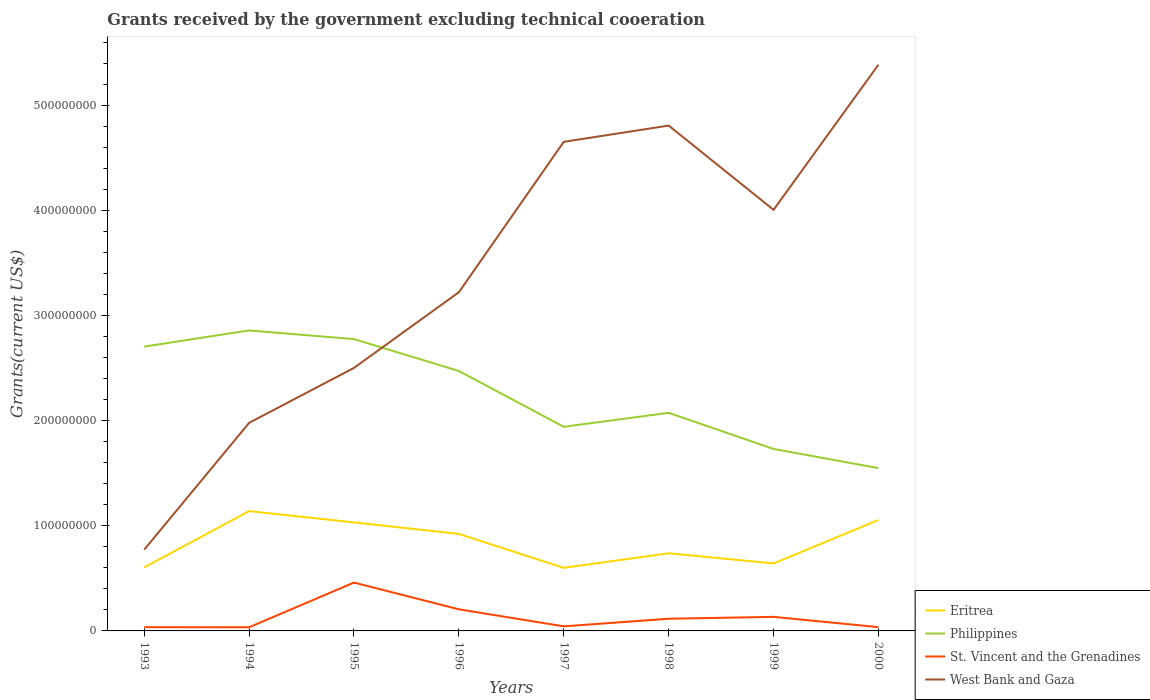How many different coloured lines are there?
Your response must be concise. 4. Does the line corresponding to West Bank and Gaza intersect with the line corresponding to Philippines?
Offer a very short reply. Yes. Is the number of lines equal to the number of legend labels?
Your answer should be very brief. Yes. Across all years, what is the maximum total grants received by the government in West Bank and Gaza?
Your answer should be compact. 7.73e+07. What is the total total grants received by the government in Eritrea in the graph?
Keep it short and to the point. 2.81e+07. What is the difference between the highest and the second highest total grants received by the government in Eritrea?
Make the answer very short. 5.39e+07. What is the difference between the highest and the lowest total grants received by the government in St. Vincent and the Grenadines?
Your answer should be compact. 3. Is the total grants received by the government in Philippines strictly greater than the total grants received by the government in St. Vincent and the Grenadines over the years?
Offer a terse response. No. How many lines are there?
Keep it short and to the point. 4. What is the difference between two consecutive major ticks on the Y-axis?
Ensure brevity in your answer.  1.00e+08. Are the values on the major ticks of Y-axis written in scientific E-notation?
Give a very brief answer. No. Where does the legend appear in the graph?
Provide a succinct answer. Bottom right. How are the legend labels stacked?
Offer a very short reply. Vertical. What is the title of the graph?
Your response must be concise. Grants received by the government excluding technical cooeration. Does "Libya" appear as one of the legend labels in the graph?
Ensure brevity in your answer.  No. What is the label or title of the X-axis?
Offer a terse response. Years. What is the label or title of the Y-axis?
Your answer should be compact. Grants(current US$). What is the Grants(current US$) of Eritrea in 1993?
Your answer should be compact. 6.04e+07. What is the Grants(current US$) of Philippines in 1993?
Your answer should be compact. 2.70e+08. What is the Grants(current US$) of St. Vincent and the Grenadines in 1993?
Give a very brief answer. 3.53e+06. What is the Grants(current US$) of West Bank and Gaza in 1993?
Provide a short and direct response. 7.73e+07. What is the Grants(current US$) of Eritrea in 1994?
Provide a short and direct response. 1.14e+08. What is the Grants(current US$) in Philippines in 1994?
Your answer should be very brief. 2.86e+08. What is the Grants(current US$) in St. Vincent and the Grenadines in 1994?
Give a very brief answer. 3.47e+06. What is the Grants(current US$) in West Bank and Gaza in 1994?
Provide a succinct answer. 1.98e+08. What is the Grants(current US$) of Eritrea in 1995?
Make the answer very short. 1.03e+08. What is the Grants(current US$) of Philippines in 1995?
Give a very brief answer. 2.78e+08. What is the Grants(current US$) of St. Vincent and the Grenadines in 1995?
Your response must be concise. 4.60e+07. What is the Grants(current US$) of West Bank and Gaza in 1995?
Give a very brief answer. 2.50e+08. What is the Grants(current US$) of Eritrea in 1996?
Offer a terse response. 9.22e+07. What is the Grants(current US$) in Philippines in 1996?
Provide a succinct answer. 2.47e+08. What is the Grants(current US$) in St. Vincent and the Grenadines in 1996?
Ensure brevity in your answer.  2.06e+07. What is the Grants(current US$) in West Bank and Gaza in 1996?
Offer a terse response. 3.22e+08. What is the Grants(current US$) of Eritrea in 1997?
Provide a short and direct response. 6.00e+07. What is the Grants(current US$) in Philippines in 1997?
Provide a short and direct response. 1.94e+08. What is the Grants(current US$) in St. Vincent and the Grenadines in 1997?
Make the answer very short. 4.35e+06. What is the Grants(current US$) in West Bank and Gaza in 1997?
Your response must be concise. 4.65e+08. What is the Grants(current US$) of Eritrea in 1998?
Offer a very short reply. 7.39e+07. What is the Grants(current US$) of Philippines in 1998?
Offer a terse response. 2.07e+08. What is the Grants(current US$) in St. Vincent and the Grenadines in 1998?
Ensure brevity in your answer.  1.16e+07. What is the Grants(current US$) of West Bank and Gaza in 1998?
Your answer should be very brief. 4.81e+08. What is the Grants(current US$) in Eritrea in 1999?
Keep it short and to the point. 6.42e+07. What is the Grants(current US$) of Philippines in 1999?
Your response must be concise. 1.73e+08. What is the Grants(current US$) of St. Vincent and the Grenadines in 1999?
Give a very brief answer. 1.34e+07. What is the Grants(current US$) of West Bank and Gaza in 1999?
Keep it short and to the point. 4.01e+08. What is the Grants(current US$) in Eritrea in 2000?
Offer a very short reply. 1.06e+08. What is the Grants(current US$) in Philippines in 2000?
Provide a succinct answer. 1.55e+08. What is the Grants(current US$) in St. Vincent and the Grenadines in 2000?
Provide a short and direct response. 3.59e+06. What is the Grants(current US$) in West Bank and Gaza in 2000?
Give a very brief answer. 5.39e+08. Across all years, what is the maximum Grants(current US$) of Eritrea?
Your answer should be compact. 1.14e+08. Across all years, what is the maximum Grants(current US$) in Philippines?
Ensure brevity in your answer.  2.86e+08. Across all years, what is the maximum Grants(current US$) of St. Vincent and the Grenadines?
Provide a short and direct response. 4.60e+07. Across all years, what is the maximum Grants(current US$) in West Bank and Gaza?
Offer a very short reply. 5.39e+08. Across all years, what is the minimum Grants(current US$) in Eritrea?
Your answer should be very brief. 6.00e+07. Across all years, what is the minimum Grants(current US$) in Philippines?
Your answer should be compact. 1.55e+08. Across all years, what is the minimum Grants(current US$) of St. Vincent and the Grenadines?
Provide a short and direct response. 3.47e+06. Across all years, what is the minimum Grants(current US$) in West Bank and Gaza?
Offer a terse response. 7.73e+07. What is the total Grants(current US$) of Eritrea in the graph?
Keep it short and to the point. 6.73e+08. What is the total Grants(current US$) of Philippines in the graph?
Provide a succinct answer. 1.81e+09. What is the total Grants(current US$) of St. Vincent and the Grenadines in the graph?
Provide a short and direct response. 1.06e+08. What is the total Grants(current US$) in West Bank and Gaza in the graph?
Give a very brief answer. 2.73e+09. What is the difference between the Grants(current US$) of Eritrea in 1993 and that in 1994?
Offer a very short reply. -5.35e+07. What is the difference between the Grants(current US$) in Philippines in 1993 and that in 1994?
Make the answer very short. -1.54e+07. What is the difference between the Grants(current US$) of West Bank and Gaza in 1993 and that in 1994?
Provide a short and direct response. -1.21e+08. What is the difference between the Grants(current US$) in Eritrea in 1993 and that in 1995?
Your answer should be very brief. -4.28e+07. What is the difference between the Grants(current US$) of Philippines in 1993 and that in 1995?
Your answer should be very brief. -7.13e+06. What is the difference between the Grants(current US$) in St. Vincent and the Grenadines in 1993 and that in 1995?
Your answer should be compact. -4.24e+07. What is the difference between the Grants(current US$) in West Bank and Gaza in 1993 and that in 1995?
Keep it short and to the point. -1.73e+08. What is the difference between the Grants(current US$) of Eritrea in 1993 and that in 1996?
Your answer should be compact. -3.18e+07. What is the difference between the Grants(current US$) of Philippines in 1993 and that in 1996?
Keep it short and to the point. 2.32e+07. What is the difference between the Grants(current US$) of St. Vincent and the Grenadines in 1993 and that in 1996?
Offer a terse response. -1.70e+07. What is the difference between the Grants(current US$) in West Bank and Gaza in 1993 and that in 1996?
Provide a short and direct response. -2.45e+08. What is the difference between the Grants(current US$) of Philippines in 1993 and that in 1997?
Make the answer very short. 7.63e+07. What is the difference between the Grants(current US$) in St. Vincent and the Grenadines in 1993 and that in 1997?
Offer a very short reply. -8.20e+05. What is the difference between the Grants(current US$) in West Bank and Gaza in 1993 and that in 1997?
Ensure brevity in your answer.  -3.88e+08. What is the difference between the Grants(current US$) of Eritrea in 1993 and that in 1998?
Offer a very short reply. -1.35e+07. What is the difference between the Grants(current US$) in Philippines in 1993 and that in 1998?
Your response must be concise. 6.30e+07. What is the difference between the Grants(current US$) in St. Vincent and the Grenadines in 1993 and that in 1998?
Make the answer very short. -8.06e+06. What is the difference between the Grants(current US$) of West Bank and Gaza in 1993 and that in 1998?
Your answer should be very brief. -4.03e+08. What is the difference between the Grants(current US$) in Eritrea in 1993 and that in 1999?
Your answer should be very brief. -3.78e+06. What is the difference between the Grants(current US$) in Philippines in 1993 and that in 1999?
Give a very brief answer. 9.74e+07. What is the difference between the Grants(current US$) of St. Vincent and the Grenadines in 1993 and that in 1999?
Give a very brief answer. -9.84e+06. What is the difference between the Grants(current US$) of West Bank and Gaza in 1993 and that in 1999?
Offer a very short reply. -3.23e+08. What is the difference between the Grants(current US$) in Eritrea in 1993 and that in 2000?
Your answer should be very brief. -4.51e+07. What is the difference between the Grants(current US$) of Philippines in 1993 and that in 2000?
Provide a succinct answer. 1.16e+08. What is the difference between the Grants(current US$) of St. Vincent and the Grenadines in 1993 and that in 2000?
Provide a short and direct response. -6.00e+04. What is the difference between the Grants(current US$) in West Bank and Gaza in 1993 and that in 2000?
Your answer should be very brief. -4.61e+08. What is the difference between the Grants(current US$) in Eritrea in 1994 and that in 1995?
Your answer should be very brief. 1.07e+07. What is the difference between the Grants(current US$) in Philippines in 1994 and that in 1995?
Make the answer very short. 8.22e+06. What is the difference between the Grants(current US$) in St. Vincent and the Grenadines in 1994 and that in 1995?
Make the answer very short. -4.25e+07. What is the difference between the Grants(current US$) of West Bank and Gaza in 1994 and that in 1995?
Offer a very short reply. -5.23e+07. What is the difference between the Grants(current US$) in Eritrea in 1994 and that in 1996?
Your response must be concise. 2.17e+07. What is the difference between the Grants(current US$) of Philippines in 1994 and that in 1996?
Keep it short and to the point. 3.86e+07. What is the difference between the Grants(current US$) of St. Vincent and the Grenadines in 1994 and that in 1996?
Make the answer very short. -1.71e+07. What is the difference between the Grants(current US$) in West Bank and Gaza in 1994 and that in 1996?
Provide a succinct answer. -1.24e+08. What is the difference between the Grants(current US$) in Eritrea in 1994 and that in 1997?
Provide a succinct answer. 5.39e+07. What is the difference between the Grants(current US$) of Philippines in 1994 and that in 1997?
Ensure brevity in your answer.  9.16e+07. What is the difference between the Grants(current US$) in St. Vincent and the Grenadines in 1994 and that in 1997?
Your answer should be very brief. -8.80e+05. What is the difference between the Grants(current US$) in West Bank and Gaza in 1994 and that in 1997?
Your answer should be compact. -2.67e+08. What is the difference between the Grants(current US$) of Eritrea in 1994 and that in 1998?
Provide a short and direct response. 4.01e+07. What is the difference between the Grants(current US$) in Philippines in 1994 and that in 1998?
Provide a succinct answer. 7.84e+07. What is the difference between the Grants(current US$) of St. Vincent and the Grenadines in 1994 and that in 1998?
Your response must be concise. -8.12e+06. What is the difference between the Grants(current US$) in West Bank and Gaza in 1994 and that in 1998?
Keep it short and to the point. -2.83e+08. What is the difference between the Grants(current US$) in Eritrea in 1994 and that in 1999?
Give a very brief answer. 4.98e+07. What is the difference between the Grants(current US$) of Philippines in 1994 and that in 1999?
Your answer should be very brief. 1.13e+08. What is the difference between the Grants(current US$) in St. Vincent and the Grenadines in 1994 and that in 1999?
Your answer should be compact. -9.90e+06. What is the difference between the Grants(current US$) of West Bank and Gaza in 1994 and that in 1999?
Provide a short and direct response. -2.03e+08. What is the difference between the Grants(current US$) in Eritrea in 1994 and that in 2000?
Provide a succinct answer. 8.42e+06. What is the difference between the Grants(current US$) in Philippines in 1994 and that in 2000?
Provide a short and direct response. 1.31e+08. What is the difference between the Grants(current US$) in St. Vincent and the Grenadines in 1994 and that in 2000?
Your answer should be compact. -1.20e+05. What is the difference between the Grants(current US$) in West Bank and Gaza in 1994 and that in 2000?
Ensure brevity in your answer.  -3.41e+08. What is the difference between the Grants(current US$) in Eritrea in 1995 and that in 1996?
Offer a very short reply. 1.10e+07. What is the difference between the Grants(current US$) in Philippines in 1995 and that in 1996?
Ensure brevity in your answer.  3.04e+07. What is the difference between the Grants(current US$) in St. Vincent and the Grenadines in 1995 and that in 1996?
Provide a succinct answer. 2.54e+07. What is the difference between the Grants(current US$) of West Bank and Gaza in 1995 and that in 1996?
Keep it short and to the point. -7.20e+07. What is the difference between the Grants(current US$) in Eritrea in 1995 and that in 1997?
Offer a very short reply. 4.32e+07. What is the difference between the Grants(current US$) of Philippines in 1995 and that in 1997?
Provide a succinct answer. 8.34e+07. What is the difference between the Grants(current US$) in St. Vincent and the Grenadines in 1995 and that in 1997?
Ensure brevity in your answer.  4.16e+07. What is the difference between the Grants(current US$) of West Bank and Gaza in 1995 and that in 1997?
Your answer should be very brief. -2.15e+08. What is the difference between the Grants(current US$) in Eritrea in 1995 and that in 1998?
Keep it short and to the point. 2.94e+07. What is the difference between the Grants(current US$) in Philippines in 1995 and that in 1998?
Your answer should be very brief. 7.01e+07. What is the difference between the Grants(current US$) of St. Vincent and the Grenadines in 1995 and that in 1998?
Provide a short and direct response. 3.44e+07. What is the difference between the Grants(current US$) of West Bank and Gaza in 1995 and that in 1998?
Make the answer very short. -2.30e+08. What is the difference between the Grants(current US$) in Eritrea in 1995 and that in 1999?
Offer a terse response. 3.90e+07. What is the difference between the Grants(current US$) in Philippines in 1995 and that in 1999?
Your answer should be compact. 1.04e+08. What is the difference between the Grants(current US$) of St. Vincent and the Grenadines in 1995 and that in 1999?
Offer a very short reply. 3.26e+07. What is the difference between the Grants(current US$) of West Bank and Gaza in 1995 and that in 1999?
Provide a short and direct response. -1.50e+08. What is the difference between the Grants(current US$) in Eritrea in 1995 and that in 2000?
Your response must be concise. -2.29e+06. What is the difference between the Grants(current US$) of Philippines in 1995 and that in 2000?
Provide a succinct answer. 1.23e+08. What is the difference between the Grants(current US$) in St. Vincent and the Grenadines in 1995 and that in 2000?
Offer a very short reply. 4.24e+07. What is the difference between the Grants(current US$) of West Bank and Gaza in 1995 and that in 2000?
Offer a very short reply. -2.88e+08. What is the difference between the Grants(current US$) in Eritrea in 1996 and that in 1997?
Offer a very short reply. 3.22e+07. What is the difference between the Grants(current US$) of Philippines in 1996 and that in 1997?
Provide a short and direct response. 5.30e+07. What is the difference between the Grants(current US$) in St. Vincent and the Grenadines in 1996 and that in 1997?
Ensure brevity in your answer.  1.62e+07. What is the difference between the Grants(current US$) of West Bank and Gaza in 1996 and that in 1997?
Your answer should be very brief. -1.43e+08. What is the difference between the Grants(current US$) in Eritrea in 1996 and that in 1998?
Your response must be concise. 1.84e+07. What is the difference between the Grants(current US$) of Philippines in 1996 and that in 1998?
Your response must be concise. 3.98e+07. What is the difference between the Grants(current US$) in St. Vincent and the Grenadines in 1996 and that in 1998?
Provide a succinct answer. 8.96e+06. What is the difference between the Grants(current US$) in West Bank and Gaza in 1996 and that in 1998?
Give a very brief answer. -1.59e+08. What is the difference between the Grants(current US$) in Eritrea in 1996 and that in 1999?
Your response must be concise. 2.81e+07. What is the difference between the Grants(current US$) in Philippines in 1996 and that in 1999?
Your answer should be compact. 7.41e+07. What is the difference between the Grants(current US$) of St. Vincent and the Grenadines in 1996 and that in 1999?
Keep it short and to the point. 7.18e+06. What is the difference between the Grants(current US$) in West Bank and Gaza in 1996 and that in 1999?
Your response must be concise. -7.84e+07. What is the difference between the Grants(current US$) in Eritrea in 1996 and that in 2000?
Make the answer very short. -1.33e+07. What is the difference between the Grants(current US$) of Philippines in 1996 and that in 2000?
Offer a terse response. 9.24e+07. What is the difference between the Grants(current US$) of St. Vincent and the Grenadines in 1996 and that in 2000?
Your response must be concise. 1.70e+07. What is the difference between the Grants(current US$) in West Bank and Gaza in 1996 and that in 2000?
Your answer should be very brief. -2.16e+08. What is the difference between the Grants(current US$) of Eritrea in 1997 and that in 1998?
Your response must be concise. -1.38e+07. What is the difference between the Grants(current US$) in Philippines in 1997 and that in 1998?
Give a very brief answer. -1.33e+07. What is the difference between the Grants(current US$) of St. Vincent and the Grenadines in 1997 and that in 1998?
Offer a very short reply. -7.24e+06. What is the difference between the Grants(current US$) in West Bank and Gaza in 1997 and that in 1998?
Ensure brevity in your answer.  -1.54e+07. What is the difference between the Grants(current US$) in Eritrea in 1997 and that in 1999?
Provide a short and direct response. -4.17e+06. What is the difference between the Grants(current US$) in Philippines in 1997 and that in 1999?
Keep it short and to the point. 2.11e+07. What is the difference between the Grants(current US$) in St. Vincent and the Grenadines in 1997 and that in 1999?
Provide a succinct answer. -9.02e+06. What is the difference between the Grants(current US$) of West Bank and Gaza in 1997 and that in 1999?
Ensure brevity in your answer.  6.47e+07. What is the difference between the Grants(current US$) in Eritrea in 1997 and that in 2000?
Keep it short and to the point. -4.55e+07. What is the difference between the Grants(current US$) in Philippines in 1997 and that in 2000?
Offer a terse response. 3.93e+07. What is the difference between the Grants(current US$) in St. Vincent and the Grenadines in 1997 and that in 2000?
Provide a succinct answer. 7.60e+05. What is the difference between the Grants(current US$) in West Bank and Gaza in 1997 and that in 2000?
Your answer should be very brief. -7.34e+07. What is the difference between the Grants(current US$) of Eritrea in 1998 and that in 1999?
Offer a very short reply. 9.68e+06. What is the difference between the Grants(current US$) in Philippines in 1998 and that in 1999?
Keep it short and to the point. 3.44e+07. What is the difference between the Grants(current US$) of St. Vincent and the Grenadines in 1998 and that in 1999?
Offer a terse response. -1.78e+06. What is the difference between the Grants(current US$) in West Bank and Gaza in 1998 and that in 1999?
Your answer should be compact. 8.02e+07. What is the difference between the Grants(current US$) of Eritrea in 1998 and that in 2000?
Make the answer very short. -3.17e+07. What is the difference between the Grants(current US$) of Philippines in 1998 and that in 2000?
Make the answer very short. 5.26e+07. What is the difference between the Grants(current US$) in St. Vincent and the Grenadines in 1998 and that in 2000?
Your response must be concise. 8.00e+06. What is the difference between the Grants(current US$) in West Bank and Gaza in 1998 and that in 2000?
Make the answer very short. -5.79e+07. What is the difference between the Grants(current US$) of Eritrea in 1999 and that in 2000?
Provide a short and direct response. -4.13e+07. What is the difference between the Grants(current US$) in Philippines in 1999 and that in 2000?
Offer a very short reply. 1.82e+07. What is the difference between the Grants(current US$) in St. Vincent and the Grenadines in 1999 and that in 2000?
Your answer should be very brief. 9.78e+06. What is the difference between the Grants(current US$) in West Bank and Gaza in 1999 and that in 2000?
Your response must be concise. -1.38e+08. What is the difference between the Grants(current US$) of Eritrea in 1993 and the Grants(current US$) of Philippines in 1994?
Your answer should be very brief. -2.25e+08. What is the difference between the Grants(current US$) of Eritrea in 1993 and the Grants(current US$) of St. Vincent and the Grenadines in 1994?
Make the answer very short. 5.69e+07. What is the difference between the Grants(current US$) in Eritrea in 1993 and the Grants(current US$) in West Bank and Gaza in 1994?
Your answer should be compact. -1.38e+08. What is the difference between the Grants(current US$) in Philippines in 1993 and the Grants(current US$) in St. Vincent and the Grenadines in 1994?
Ensure brevity in your answer.  2.67e+08. What is the difference between the Grants(current US$) of Philippines in 1993 and the Grants(current US$) of West Bank and Gaza in 1994?
Give a very brief answer. 7.25e+07. What is the difference between the Grants(current US$) of St. Vincent and the Grenadines in 1993 and the Grants(current US$) of West Bank and Gaza in 1994?
Make the answer very short. -1.94e+08. What is the difference between the Grants(current US$) of Eritrea in 1993 and the Grants(current US$) of Philippines in 1995?
Provide a short and direct response. -2.17e+08. What is the difference between the Grants(current US$) of Eritrea in 1993 and the Grants(current US$) of St. Vincent and the Grenadines in 1995?
Keep it short and to the point. 1.44e+07. What is the difference between the Grants(current US$) in Eritrea in 1993 and the Grants(current US$) in West Bank and Gaza in 1995?
Your response must be concise. -1.90e+08. What is the difference between the Grants(current US$) in Philippines in 1993 and the Grants(current US$) in St. Vincent and the Grenadines in 1995?
Make the answer very short. 2.24e+08. What is the difference between the Grants(current US$) of Philippines in 1993 and the Grants(current US$) of West Bank and Gaza in 1995?
Offer a terse response. 2.03e+07. What is the difference between the Grants(current US$) of St. Vincent and the Grenadines in 1993 and the Grants(current US$) of West Bank and Gaza in 1995?
Provide a succinct answer. -2.47e+08. What is the difference between the Grants(current US$) of Eritrea in 1993 and the Grants(current US$) of Philippines in 1996?
Make the answer very short. -1.87e+08. What is the difference between the Grants(current US$) in Eritrea in 1993 and the Grants(current US$) in St. Vincent and the Grenadines in 1996?
Give a very brief answer. 3.98e+07. What is the difference between the Grants(current US$) in Eritrea in 1993 and the Grants(current US$) in West Bank and Gaza in 1996?
Ensure brevity in your answer.  -2.62e+08. What is the difference between the Grants(current US$) of Philippines in 1993 and the Grants(current US$) of St. Vincent and the Grenadines in 1996?
Provide a succinct answer. 2.50e+08. What is the difference between the Grants(current US$) of Philippines in 1993 and the Grants(current US$) of West Bank and Gaza in 1996?
Provide a succinct answer. -5.17e+07. What is the difference between the Grants(current US$) in St. Vincent and the Grenadines in 1993 and the Grants(current US$) in West Bank and Gaza in 1996?
Offer a terse response. -3.19e+08. What is the difference between the Grants(current US$) of Eritrea in 1993 and the Grants(current US$) of Philippines in 1997?
Provide a succinct answer. -1.34e+08. What is the difference between the Grants(current US$) of Eritrea in 1993 and the Grants(current US$) of St. Vincent and the Grenadines in 1997?
Ensure brevity in your answer.  5.60e+07. What is the difference between the Grants(current US$) in Eritrea in 1993 and the Grants(current US$) in West Bank and Gaza in 1997?
Your answer should be very brief. -4.05e+08. What is the difference between the Grants(current US$) of Philippines in 1993 and the Grants(current US$) of St. Vincent and the Grenadines in 1997?
Make the answer very short. 2.66e+08. What is the difference between the Grants(current US$) of Philippines in 1993 and the Grants(current US$) of West Bank and Gaza in 1997?
Give a very brief answer. -1.95e+08. What is the difference between the Grants(current US$) of St. Vincent and the Grenadines in 1993 and the Grants(current US$) of West Bank and Gaza in 1997?
Your response must be concise. -4.62e+08. What is the difference between the Grants(current US$) of Eritrea in 1993 and the Grants(current US$) of Philippines in 1998?
Your answer should be very brief. -1.47e+08. What is the difference between the Grants(current US$) in Eritrea in 1993 and the Grants(current US$) in St. Vincent and the Grenadines in 1998?
Offer a terse response. 4.88e+07. What is the difference between the Grants(current US$) of Eritrea in 1993 and the Grants(current US$) of West Bank and Gaza in 1998?
Your answer should be very brief. -4.20e+08. What is the difference between the Grants(current US$) in Philippines in 1993 and the Grants(current US$) in St. Vincent and the Grenadines in 1998?
Offer a very short reply. 2.59e+08. What is the difference between the Grants(current US$) in Philippines in 1993 and the Grants(current US$) in West Bank and Gaza in 1998?
Ensure brevity in your answer.  -2.10e+08. What is the difference between the Grants(current US$) in St. Vincent and the Grenadines in 1993 and the Grants(current US$) in West Bank and Gaza in 1998?
Provide a succinct answer. -4.77e+08. What is the difference between the Grants(current US$) of Eritrea in 1993 and the Grants(current US$) of Philippines in 1999?
Offer a very short reply. -1.13e+08. What is the difference between the Grants(current US$) of Eritrea in 1993 and the Grants(current US$) of St. Vincent and the Grenadines in 1999?
Keep it short and to the point. 4.70e+07. What is the difference between the Grants(current US$) of Eritrea in 1993 and the Grants(current US$) of West Bank and Gaza in 1999?
Your answer should be compact. -3.40e+08. What is the difference between the Grants(current US$) in Philippines in 1993 and the Grants(current US$) in St. Vincent and the Grenadines in 1999?
Provide a succinct answer. 2.57e+08. What is the difference between the Grants(current US$) in Philippines in 1993 and the Grants(current US$) in West Bank and Gaza in 1999?
Keep it short and to the point. -1.30e+08. What is the difference between the Grants(current US$) of St. Vincent and the Grenadines in 1993 and the Grants(current US$) of West Bank and Gaza in 1999?
Offer a very short reply. -3.97e+08. What is the difference between the Grants(current US$) in Eritrea in 1993 and the Grants(current US$) in Philippines in 2000?
Offer a terse response. -9.45e+07. What is the difference between the Grants(current US$) in Eritrea in 1993 and the Grants(current US$) in St. Vincent and the Grenadines in 2000?
Provide a succinct answer. 5.68e+07. What is the difference between the Grants(current US$) of Eritrea in 1993 and the Grants(current US$) of West Bank and Gaza in 2000?
Offer a very short reply. -4.78e+08. What is the difference between the Grants(current US$) of Philippines in 1993 and the Grants(current US$) of St. Vincent and the Grenadines in 2000?
Ensure brevity in your answer.  2.67e+08. What is the difference between the Grants(current US$) in Philippines in 1993 and the Grants(current US$) in West Bank and Gaza in 2000?
Make the answer very short. -2.68e+08. What is the difference between the Grants(current US$) of St. Vincent and the Grenadines in 1993 and the Grants(current US$) of West Bank and Gaza in 2000?
Your answer should be very brief. -5.35e+08. What is the difference between the Grants(current US$) of Eritrea in 1994 and the Grants(current US$) of Philippines in 1995?
Offer a very short reply. -1.64e+08. What is the difference between the Grants(current US$) in Eritrea in 1994 and the Grants(current US$) in St. Vincent and the Grenadines in 1995?
Your answer should be very brief. 6.80e+07. What is the difference between the Grants(current US$) of Eritrea in 1994 and the Grants(current US$) of West Bank and Gaza in 1995?
Make the answer very short. -1.36e+08. What is the difference between the Grants(current US$) in Philippines in 1994 and the Grants(current US$) in St. Vincent and the Grenadines in 1995?
Your answer should be very brief. 2.40e+08. What is the difference between the Grants(current US$) of Philippines in 1994 and the Grants(current US$) of West Bank and Gaza in 1995?
Your response must be concise. 3.56e+07. What is the difference between the Grants(current US$) in St. Vincent and the Grenadines in 1994 and the Grants(current US$) in West Bank and Gaza in 1995?
Keep it short and to the point. -2.47e+08. What is the difference between the Grants(current US$) of Eritrea in 1994 and the Grants(current US$) of Philippines in 1996?
Ensure brevity in your answer.  -1.33e+08. What is the difference between the Grants(current US$) of Eritrea in 1994 and the Grants(current US$) of St. Vincent and the Grenadines in 1996?
Ensure brevity in your answer.  9.34e+07. What is the difference between the Grants(current US$) of Eritrea in 1994 and the Grants(current US$) of West Bank and Gaza in 1996?
Offer a very short reply. -2.08e+08. What is the difference between the Grants(current US$) in Philippines in 1994 and the Grants(current US$) in St. Vincent and the Grenadines in 1996?
Offer a very short reply. 2.65e+08. What is the difference between the Grants(current US$) in Philippines in 1994 and the Grants(current US$) in West Bank and Gaza in 1996?
Ensure brevity in your answer.  -3.64e+07. What is the difference between the Grants(current US$) in St. Vincent and the Grenadines in 1994 and the Grants(current US$) in West Bank and Gaza in 1996?
Make the answer very short. -3.19e+08. What is the difference between the Grants(current US$) of Eritrea in 1994 and the Grants(current US$) of Philippines in 1997?
Make the answer very short. -8.02e+07. What is the difference between the Grants(current US$) in Eritrea in 1994 and the Grants(current US$) in St. Vincent and the Grenadines in 1997?
Give a very brief answer. 1.10e+08. What is the difference between the Grants(current US$) of Eritrea in 1994 and the Grants(current US$) of West Bank and Gaza in 1997?
Ensure brevity in your answer.  -3.51e+08. What is the difference between the Grants(current US$) of Philippines in 1994 and the Grants(current US$) of St. Vincent and the Grenadines in 1997?
Your answer should be compact. 2.81e+08. What is the difference between the Grants(current US$) in Philippines in 1994 and the Grants(current US$) in West Bank and Gaza in 1997?
Give a very brief answer. -1.79e+08. What is the difference between the Grants(current US$) of St. Vincent and the Grenadines in 1994 and the Grants(current US$) of West Bank and Gaza in 1997?
Your answer should be compact. -4.62e+08. What is the difference between the Grants(current US$) of Eritrea in 1994 and the Grants(current US$) of Philippines in 1998?
Keep it short and to the point. -9.35e+07. What is the difference between the Grants(current US$) in Eritrea in 1994 and the Grants(current US$) in St. Vincent and the Grenadines in 1998?
Provide a succinct answer. 1.02e+08. What is the difference between the Grants(current US$) in Eritrea in 1994 and the Grants(current US$) in West Bank and Gaza in 1998?
Provide a short and direct response. -3.67e+08. What is the difference between the Grants(current US$) in Philippines in 1994 and the Grants(current US$) in St. Vincent and the Grenadines in 1998?
Your response must be concise. 2.74e+08. What is the difference between the Grants(current US$) of Philippines in 1994 and the Grants(current US$) of West Bank and Gaza in 1998?
Your response must be concise. -1.95e+08. What is the difference between the Grants(current US$) in St. Vincent and the Grenadines in 1994 and the Grants(current US$) in West Bank and Gaza in 1998?
Your answer should be very brief. -4.77e+08. What is the difference between the Grants(current US$) in Eritrea in 1994 and the Grants(current US$) in Philippines in 1999?
Offer a terse response. -5.91e+07. What is the difference between the Grants(current US$) in Eritrea in 1994 and the Grants(current US$) in St. Vincent and the Grenadines in 1999?
Your answer should be very brief. 1.01e+08. What is the difference between the Grants(current US$) of Eritrea in 1994 and the Grants(current US$) of West Bank and Gaza in 1999?
Provide a short and direct response. -2.87e+08. What is the difference between the Grants(current US$) of Philippines in 1994 and the Grants(current US$) of St. Vincent and the Grenadines in 1999?
Ensure brevity in your answer.  2.72e+08. What is the difference between the Grants(current US$) in Philippines in 1994 and the Grants(current US$) in West Bank and Gaza in 1999?
Offer a terse response. -1.15e+08. What is the difference between the Grants(current US$) in St. Vincent and the Grenadines in 1994 and the Grants(current US$) in West Bank and Gaza in 1999?
Provide a short and direct response. -3.97e+08. What is the difference between the Grants(current US$) of Eritrea in 1994 and the Grants(current US$) of Philippines in 2000?
Your answer should be very brief. -4.09e+07. What is the difference between the Grants(current US$) of Eritrea in 1994 and the Grants(current US$) of St. Vincent and the Grenadines in 2000?
Your answer should be compact. 1.10e+08. What is the difference between the Grants(current US$) of Eritrea in 1994 and the Grants(current US$) of West Bank and Gaza in 2000?
Offer a terse response. -4.25e+08. What is the difference between the Grants(current US$) of Philippines in 1994 and the Grants(current US$) of St. Vincent and the Grenadines in 2000?
Your answer should be compact. 2.82e+08. What is the difference between the Grants(current US$) in Philippines in 1994 and the Grants(current US$) in West Bank and Gaza in 2000?
Your answer should be compact. -2.53e+08. What is the difference between the Grants(current US$) in St. Vincent and the Grenadines in 1994 and the Grants(current US$) in West Bank and Gaza in 2000?
Provide a succinct answer. -5.35e+08. What is the difference between the Grants(current US$) of Eritrea in 1995 and the Grants(current US$) of Philippines in 1996?
Offer a terse response. -1.44e+08. What is the difference between the Grants(current US$) in Eritrea in 1995 and the Grants(current US$) in St. Vincent and the Grenadines in 1996?
Offer a very short reply. 8.27e+07. What is the difference between the Grants(current US$) of Eritrea in 1995 and the Grants(current US$) of West Bank and Gaza in 1996?
Provide a short and direct response. -2.19e+08. What is the difference between the Grants(current US$) in Philippines in 1995 and the Grants(current US$) in St. Vincent and the Grenadines in 1996?
Make the answer very short. 2.57e+08. What is the difference between the Grants(current US$) of Philippines in 1995 and the Grants(current US$) of West Bank and Gaza in 1996?
Offer a very short reply. -4.46e+07. What is the difference between the Grants(current US$) in St. Vincent and the Grenadines in 1995 and the Grants(current US$) in West Bank and Gaza in 1996?
Keep it short and to the point. -2.76e+08. What is the difference between the Grants(current US$) of Eritrea in 1995 and the Grants(current US$) of Philippines in 1997?
Keep it short and to the point. -9.10e+07. What is the difference between the Grants(current US$) of Eritrea in 1995 and the Grants(current US$) of St. Vincent and the Grenadines in 1997?
Your response must be concise. 9.89e+07. What is the difference between the Grants(current US$) in Eritrea in 1995 and the Grants(current US$) in West Bank and Gaza in 1997?
Make the answer very short. -3.62e+08. What is the difference between the Grants(current US$) in Philippines in 1995 and the Grants(current US$) in St. Vincent and the Grenadines in 1997?
Your response must be concise. 2.73e+08. What is the difference between the Grants(current US$) in Philippines in 1995 and the Grants(current US$) in West Bank and Gaza in 1997?
Your answer should be very brief. -1.88e+08. What is the difference between the Grants(current US$) of St. Vincent and the Grenadines in 1995 and the Grants(current US$) of West Bank and Gaza in 1997?
Ensure brevity in your answer.  -4.19e+08. What is the difference between the Grants(current US$) of Eritrea in 1995 and the Grants(current US$) of Philippines in 1998?
Your answer should be very brief. -1.04e+08. What is the difference between the Grants(current US$) in Eritrea in 1995 and the Grants(current US$) in St. Vincent and the Grenadines in 1998?
Provide a succinct answer. 9.16e+07. What is the difference between the Grants(current US$) in Eritrea in 1995 and the Grants(current US$) in West Bank and Gaza in 1998?
Provide a succinct answer. -3.77e+08. What is the difference between the Grants(current US$) in Philippines in 1995 and the Grants(current US$) in St. Vincent and the Grenadines in 1998?
Provide a short and direct response. 2.66e+08. What is the difference between the Grants(current US$) in Philippines in 1995 and the Grants(current US$) in West Bank and Gaza in 1998?
Provide a succinct answer. -2.03e+08. What is the difference between the Grants(current US$) of St. Vincent and the Grenadines in 1995 and the Grants(current US$) of West Bank and Gaza in 1998?
Offer a very short reply. -4.35e+08. What is the difference between the Grants(current US$) of Eritrea in 1995 and the Grants(current US$) of Philippines in 1999?
Make the answer very short. -6.98e+07. What is the difference between the Grants(current US$) of Eritrea in 1995 and the Grants(current US$) of St. Vincent and the Grenadines in 1999?
Offer a very short reply. 8.99e+07. What is the difference between the Grants(current US$) of Eritrea in 1995 and the Grants(current US$) of West Bank and Gaza in 1999?
Ensure brevity in your answer.  -2.97e+08. What is the difference between the Grants(current US$) in Philippines in 1995 and the Grants(current US$) in St. Vincent and the Grenadines in 1999?
Your response must be concise. 2.64e+08. What is the difference between the Grants(current US$) of Philippines in 1995 and the Grants(current US$) of West Bank and Gaza in 1999?
Provide a succinct answer. -1.23e+08. What is the difference between the Grants(current US$) of St. Vincent and the Grenadines in 1995 and the Grants(current US$) of West Bank and Gaza in 1999?
Your answer should be compact. -3.55e+08. What is the difference between the Grants(current US$) in Eritrea in 1995 and the Grants(current US$) in Philippines in 2000?
Offer a very short reply. -5.16e+07. What is the difference between the Grants(current US$) of Eritrea in 1995 and the Grants(current US$) of St. Vincent and the Grenadines in 2000?
Provide a short and direct response. 9.96e+07. What is the difference between the Grants(current US$) of Eritrea in 1995 and the Grants(current US$) of West Bank and Gaza in 2000?
Provide a short and direct response. -4.35e+08. What is the difference between the Grants(current US$) in Philippines in 1995 and the Grants(current US$) in St. Vincent and the Grenadines in 2000?
Offer a very short reply. 2.74e+08. What is the difference between the Grants(current US$) of Philippines in 1995 and the Grants(current US$) of West Bank and Gaza in 2000?
Offer a terse response. -2.61e+08. What is the difference between the Grants(current US$) of St. Vincent and the Grenadines in 1995 and the Grants(current US$) of West Bank and Gaza in 2000?
Keep it short and to the point. -4.93e+08. What is the difference between the Grants(current US$) of Eritrea in 1996 and the Grants(current US$) of Philippines in 1997?
Offer a terse response. -1.02e+08. What is the difference between the Grants(current US$) in Eritrea in 1996 and the Grants(current US$) in St. Vincent and the Grenadines in 1997?
Keep it short and to the point. 8.79e+07. What is the difference between the Grants(current US$) of Eritrea in 1996 and the Grants(current US$) of West Bank and Gaza in 1997?
Your answer should be compact. -3.73e+08. What is the difference between the Grants(current US$) of Philippines in 1996 and the Grants(current US$) of St. Vincent and the Grenadines in 1997?
Offer a terse response. 2.43e+08. What is the difference between the Grants(current US$) of Philippines in 1996 and the Grants(current US$) of West Bank and Gaza in 1997?
Your answer should be compact. -2.18e+08. What is the difference between the Grants(current US$) in St. Vincent and the Grenadines in 1996 and the Grants(current US$) in West Bank and Gaza in 1997?
Provide a succinct answer. -4.45e+08. What is the difference between the Grants(current US$) in Eritrea in 1996 and the Grants(current US$) in Philippines in 1998?
Provide a short and direct response. -1.15e+08. What is the difference between the Grants(current US$) in Eritrea in 1996 and the Grants(current US$) in St. Vincent and the Grenadines in 1998?
Ensure brevity in your answer.  8.07e+07. What is the difference between the Grants(current US$) in Eritrea in 1996 and the Grants(current US$) in West Bank and Gaza in 1998?
Your answer should be very brief. -3.88e+08. What is the difference between the Grants(current US$) in Philippines in 1996 and the Grants(current US$) in St. Vincent and the Grenadines in 1998?
Provide a short and direct response. 2.36e+08. What is the difference between the Grants(current US$) of Philippines in 1996 and the Grants(current US$) of West Bank and Gaza in 1998?
Make the answer very short. -2.33e+08. What is the difference between the Grants(current US$) in St. Vincent and the Grenadines in 1996 and the Grants(current US$) in West Bank and Gaza in 1998?
Provide a short and direct response. -4.60e+08. What is the difference between the Grants(current US$) of Eritrea in 1996 and the Grants(current US$) of Philippines in 1999?
Your response must be concise. -8.08e+07. What is the difference between the Grants(current US$) in Eritrea in 1996 and the Grants(current US$) in St. Vincent and the Grenadines in 1999?
Your response must be concise. 7.89e+07. What is the difference between the Grants(current US$) in Eritrea in 1996 and the Grants(current US$) in West Bank and Gaza in 1999?
Keep it short and to the point. -3.08e+08. What is the difference between the Grants(current US$) of Philippines in 1996 and the Grants(current US$) of St. Vincent and the Grenadines in 1999?
Provide a succinct answer. 2.34e+08. What is the difference between the Grants(current US$) of Philippines in 1996 and the Grants(current US$) of West Bank and Gaza in 1999?
Ensure brevity in your answer.  -1.53e+08. What is the difference between the Grants(current US$) of St. Vincent and the Grenadines in 1996 and the Grants(current US$) of West Bank and Gaza in 1999?
Offer a terse response. -3.80e+08. What is the difference between the Grants(current US$) of Eritrea in 1996 and the Grants(current US$) of Philippines in 2000?
Provide a short and direct response. -6.26e+07. What is the difference between the Grants(current US$) in Eritrea in 1996 and the Grants(current US$) in St. Vincent and the Grenadines in 2000?
Offer a terse response. 8.87e+07. What is the difference between the Grants(current US$) of Eritrea in 1996 and the Grants(current US$) of West Bank and Gaza in 2000?
Your response must be concise. -4.46e+08. What is the difference between the Grants(current US$) of Philippines in 1996 and the Grants(current US$) of St. Vincent and the Grenadines in 2000?
Ensure brevity in your answer.  2.44e+08. What is the difference between the Grants(current US$) in Philippines in 1996 and the Grants(current US$) in West Bank and Gaza in 2000?
Your answer should be very brief. -2.91e+08. What is the difference between the Grants(current US$) in St. Vincent and the Grenadines in 1996 and the Grants(current US$) in West Bank and Gaza in 2000?
Your response must be concise. -5.18e+08. What is the difference between the Grants(current US$) in Eritrea in 1997 and the Grants(current US$) in Philippines in 1998?
Your answer should be compact. -1.47e+08. What is the difference between the Grants(current US$) in Eritrea in 1997 and the Grants(current US$) in St. Vincent and the Grenadines in 1998?
Give a very brief answer. 4.84e+07. What is the difference between the Grants(current US$) in Eritrea in 1997 and the Grants(current US$) in West Bank and Gaza in 1998?
Provide a succinct answer. -4.21e+08. What is the difference between the Grants(current US$) of Philippines in 1997 and the Grants(current US$) of St. Vincent and the Grenadines in 1998?
Keep it short and to the point. 1.83e+08. What is the difference between the Grants(current US$) of Philippines in 1997 and the Grants(current US$) of West Bank and Gaza in 1998?
Provide a short and direct response. -2.86e+08. What is the difference between the Grants(current US$) in St. Vincent and the Grenadines in 1997 and the Grants(current US$) in West Bank and Gaza in 1998?
Ensure brevity in your answer.  -4.76e+08. What is the difference between the Grants(current US$) in Eritrea in 1997 and the Grants(current US$) in Philippines in 1999?
Provide a succinct answer. -1.13e+08. What is the difference between the Grants(current US$) of Eritrea in 1997 and the Grants(current US$) of St. Vincent and the Grenadines in 1999?
Offer a very short reply. 4.66e+07. What is the difference between the Grants(current US$) in Eritrea in 1997 and the Grants(current US$) in West Bank and Gaza in 1999?
Your answer should be compact. -3.41e+08. What is the difference between the Grants(current US$) in Philippines in 1997 and the Grants(current US$) in St. Vincent and the Grenadines in 1999?
Offer a very short reply. 1.81e+08. What is the difference between the Grants(current US$) of Philippines in 1997 and the Grants(current US$) of West Bank and Gaza in 1999?
Your answer should be very brief. -2.06e+08. What is the difference between the Grants(current US$) in St. Vincent and the Grenadines in 1997 and the Grants(current US$) in West Bank and Gaza in 1999?
Give a very brief answer. -3.96e+08. What is the difference between the Grants(current US$) of Eritrea in 1997 and the Grants(current US$) of Philippines in 2000?
Provide a succinct answer. -9.49e+07. What is the difference between the Grants(current US$) of Eritrea in 1997 and the Grants(current US$) of St. Vincent and the Grenadines in 2000?
Ensure brevity in your answer.  5.64e+07. What is the difference between the Grants(current US$) of Eritrea in 1997 and the Grants(current US$) of West Bank and Gaza in 2000?
Your response must be concise. -4.79e+08. What is the difference between the Grants(current US$) of Philippines in 1997 and the Grants(current US$) of St. Vincent and the Grenadines in 2000?
Ensure brevity in your answer.  1.91e+08. What is the difference between the Grants(current US$) in Philippines in 1997 and the Grants(current US$) in West Bank and Gaza in 2000?
Your answer should be very brief. -3.44e+08. What is the difference between the Grants(current US$) of St. Vincent and the Grenadines in 1997 and the Grants(current US$) of West Bank and Gaza in 2000?
Give a very brief answer. -5.34e+08. What is the difference between the Grants(current US$) of Eritrea in 1998 and the Grants(current US$) of Philippines in 1999?
Your answer should be very brief. -9.92e+07. What is the difference between the Grants(current US$) in Eritrea in 1998 and the Grants(current US$) in St. Vincent and the Grenadines in 1999?
Offer a very short reply. 6.05e+07. What is the difference between the Grants(current US$) in Eritrea in 1998 and the Grants(current US$) in West Bank and Gaza in 1999?
Ensure brevity in your answer.  -3.27e+08. What is the difference between the Grants(current US$) of Philippines in 1998 and the Grants(current US$) of St. Vincent and the Grenadines in 1999?
Provide a short and direct response. 1.94e+08. What is the difference between the Grants(current US$) of Philippines in 1998 and the Grants(current US$) of West Bank and Gaza in 1999?
Offer a very short reply. -1.93e+08. What is the difference between the Grants(current US$) in St. Vincent and the Grenadines in 1998 and the Grants(current US$) in West Bank and Gaza in 1999?
Offer a terse response. -3.89e+08. What is the difference between the Grants(current US$) of Eritrea in 1998 and the Grants(current US$) of Philippines in 2000?
Your response must be concise. -8.10e+07. What is the difference between the Grants(current US$) in Eritrea in 1998 and the Grants(current US$) in St. Vincent and the Grenadines in 2000?
Provide a short and direct response. 7.03e+07. What is the difference between the Grants(current US$) in Eritrea in 1998 and the Grants(current US$) in West Bank and Gaza in 2000?
Keep it short and to the point. -4.65e+08. What is the difference between the Grants(current US$) of Philippines in 1998 and the Grants(current US$) of St. Vincent and the Grenadines in 2000?
Provide a succinct answer. 2.04e+08. What is the difference between the Grants(current US$) in Philippines in 1998 and the Grants(current US$) in West Bank and Gaza in 2000?
Provide a short and direct response. -3.31e+08. What is the difference between the Grants(current US$) in St. Vincent and the Grenadines in 1998 and the Grants(current US$) in West Bank and Gaza in 2000?
Provide a succinct answer. -5.27e+08. What is the difference between the Grants(current US$) of Eritrea in 1999 and the Grants(current US$) of Philippines in 2000?
Give a very brief answer. -9.07e+07. What is the difference between the Grants(current US$) in Eritrea in 1999 and the Grants(current US$) in St. Vincent and the Grenadines in 2000?
Provide a succinct answer. 6.06e+07. What is the difference between the Grants(current US$) of Eritrea in 1999 and the Grants(current US$) of West Bank and Gaza in 2000?
Your response must be concise. -4.74e+08. What is the difference between the Grants(current US$) of Philippines in 1999 and the Grants(current US$) of St. Vincent and the Grenadines in 2000?
Offer a very short reply. 1.69e+08. What is the difference between the Grants(current US$) of Philippines in 1999 and the Grants(current US$) of West Bank and Gaza in 2000?
Your answer should be very brief. -3.66e+08. What is the difference between the Grants(current US$) of St. Vincent and the Grenadines in 1999 and the Grants(current US$) of West Bank and Gaza in 2000?
Keep it short and to the point. -5.25e+08. What is the average Grants(current US$) in Eritrea per year?
Offer a very short reply. 8.42e+07. What is the average Grants(current US$) in Philippines per year?
Provide a succinct answer. 2.26e+08. What is the average Grants(current US$) in St. Vincent and the Grenadines per year?
Make the answer very short. 1.33e+07. What is the average Grants(current US$) in West Bank and Gaza per year?
Give a very brief answer. 3.42e+08. In the year 1993, what is the difference between the Grants(current US$) in Eritrea and Grants(current US$) in Philippines?
Give a very brief answer. -2.10e+08. In the year 1993, what is the difference between the Grants(current US$) of Eritrea and Grants(current US$) of St. Vincent and the Grenadines?
Offer a terse response. 5.69e+07. In the year 1993, what is the difference between the Grants(current US$) of Eritrea and Grants(current US$) of West Bank and Gaza?
Ensure brevity in your answer.  -1.69e+07. In the year 1993, what is the difference between the Grants(current US$) in Philippines and Grants(current US$) in St. Vincent and the Grenadines?
Give a very brief answer. 2.67e+08. In the year 1993, what is the difference between the Grants(current US$) in Philippines and Grants(current US$) in West Bank and Gaza?
Your response must be concise. 1.93e+08. In the year 1993, what is the difference between the Grants(current US$) in St. Vincent and the Grenadines and Grants(current US$) in West Bank and Gaza?
Your answer should be very brief. -7.38e+07. In the year 1994, what is the difference between the Grants(current US$) in Eritrea and Grants(current US$) in Philippines?
Provide a succinct answer. -1.72e+08. In the year 1994, what is the difference between the Grants(current US$) of Eritrea and Grants(current US$) of St. Vincent and the Grenadines?
Your answer should be compact. 1.10e+08. In the year 1994, what is the difference between the Grants(current US$) in Eritrea and Grants(current US$) in West Bank and Gaza?
Provide a short and direct response. -8.40e+07. In the year 1994, what is the difference between the Grants(current US$) of Philippines and Grants(current US$) of St. Vincent and the Grenadines?
Your response must be concise. 2.82e+08. In the year 1994, what is the difference between the Grants(current US$) of Philippines and Grants(current US$) of West Bank and Gaza?
Your answer should be very brief. 8.79e+07. In the year 1994, what is the difference between the Grants(current US$) in St. Vincent and the Grenadines and Grants(current US$) in West Bank and Gaza?
Offer a very short reply. -1.94e+08. In the year 1995, what is the difference between the Grants(current US$) of Eritrea and Grants(current US$) of Philippines?
Make the answer very short. -1.74e+08. In the year 1995, what is the difference between the Grants(current US$) of Eritrea and Grants(current US$) of St. Vincent and the Grenadines?
Ensure brevity in your answer.  5.72e+07. In the year 1995, what is the difference between the Grants(current US$) in Eritrea and Grants(current US$) in West Bank and Gaza?
Give a very brief answer. -1.47e+08. In the year 1995, what is the difference between the Grants(current US$) of Philippines and Grants(current US$) of St. Vincent and the Grenadines?
Your answer should be very brief. 2.32e+08. In the year 1995, what is the difference between the Grants(current US$) in Philippines and Grants(current US$) in West Bank and Gaza?
Provide a short and direct response. 2.74e+07. In the year 1995, what is the difference between the Grants(current US$) of St. Vincent and the Grenadines and Grants(current US$) of West Bank and Gaza?
Your response must be concise. -2.04e+08. In the year 1996, what is the difference between the Grants(current US$) in Eritrea and Grants(current US$) in Philippines?
Offer a very short reply. -1.55e+08. In the year 1996, what is the difference between the Grants(current US$) in Eritrea and Grants(current US$) in St. Vincent and the Grenadines?
Your answer should be compact. 7.17e+07. In the year 1996, what is the difference between the Grants(current US$) in Eritrea and Grants(current US$) in West Bank and Gaza?
Provide a short and direct response. -2.30e+08. In the year 1996, what is the difference between the Grants(current US$) in Philippines and Grants(current US$) in St. Vincent and the Grenadines?
Provide a short and direct response. 2.27e+08. In the year 1996, what is the difference between the Grants(current US$) of Philippines and Grants(current US$) of West Bank and Gaza?
Offer a terse response. -7.49e+07. In the year 1996, what is the difference between the Grants(current US$) of St. Vincent and the Grenadines and Grants(current US$) of West Bank and Gaza?
Offer a terse response. -3.02e+08. In the year 1997, what is the difference between the Grants(current US$) of Eritrea and Grants(current US$) of Philippines?
Provide a short and direct response. -1.34e+08. In the year 1997, what is the difference between the Grants(current US$) of Eritrea and Grants(current US$) of St. Vincent and the Grenadines?
Ensure brevity in your answer.  5.57e+07. In the year 1997, what is the difference between the Grants(current US$) of Eritrea and Grants(current US$) of West Bank and Gaza?
Your answer should be compact. -4.05e+08. In the year 1997, what is the difference between the Grants(current US$) in Philippines and Grants(current US$) in St. Vincent and the Grenadines?
Offer a very short reply. 1.90e+08. In the year 1997, what is the difference between the Grants(current US$) of Philippines and Grants(current US$) of West Bank and Gaza?
Your response must be concise. -2.71e+08. In the year 1997, what is the difference between the Grants(current US$) of St. Vincent and the Grenadines and Grants(current US$) of West Bank and Gaza?
Offer a very short reply. -4.61e+08. In the year 1998, what is the difference between the Grants(current US$) in Eritrea and Grants(current US$) in Philippines?
Keep it short and to the point. -1.34e+08. In the year 1998, what is the difference between the Grants(current US$) of Eritrea and Grants(current US$) of St. Vincent and the Grenadines?
Your response must be concise. 6.23e+07. In the year 1998, what is the difference between the Grants(current US$) in Eritrea and Grants(current US$) in West Bank and Gaza?
Make the answer very short. -4.07e+08. In the year 1998, what is the difference between the Grants(current US$) in Philippines and Grants(current US$) in St. Vincent and the Grenadines?
Offer a very short reply. 1.96e+08. In the year 1998, what is the difference between the Grants(current US$) in Philippines and Grants(current US$) in West Bank and Gaza?
Your answer should be very brief. -2.73e+08. In the year 1998, what is the difference between the Grants(current US$) of St. Vincent and the Grenadines and Grants(current US$) of West Bank and Gaza?
Your answer should be very brief. -4.69e+08. In the year 1999, what is the difference between the Grants(current US$) of Eritrea and Grants(current US$) of Philippines?
Your answer should be very brief. -1.09e+08. In the year 1999, what is the difference between the Grants(current US$) of Eritrea and Grants(current US$) of St. Vincent and the Grenadines?
Ensure brevity in your answer.  5.08e+07. In the year 1999, what is the difference between the Grants(current US$) of Eritrea and Grants(current US$) of West Bank and Gaza?
Ensure brevity in your answer.  -3.36e+08. In the year 1999, what is the difference between the Grants(current US$) in Philippines and Grants(current US$) in St. Vincent and the Grenadines?
Keep it short and to the point. 1.60e+08. In the year 1999, what is the difference between the Grants(current US$) in Philippines and Grants(current US$) in West Bank and Gaza?
Offer a very short reply. -2.27e+08. In the year 1999, what is the difference between the Grants(current US$) in St. Vincent and the Grenadines and Grants(current US$) in West Bank and Gaza?
Provide a short and direct response. -3.87e+08. In the year 2000, what is the difference between the Grants(current US$) in Eritrea and Grants(current US$) in Philippines?
Your answer should be very brief. -4.94e+07. In the year 2000, what is the difference between the Grants(current US$) in Eritrea and Grants(current US$) in St. Vincent and the Grenadines?
Provide a short and direct response. 1.02e+08. In the year 2000, what is the difference between the Grants(current US$) in Eritrea and Grants(current US$) in West Bank and Gaza?
Provide a short and direct response. -4.33e+08. In the year 2000, what is the difference between the Grants(current US$) in Philippines and Grants(current US$) in St. Vincent and the Grenadines?
Ensure brevity in your answer.  1.51e+08. In the year 2000, what is the difference between the Grants(current US$) in Philippines and Grants(current US$) in West Bank and Gaza?
Make the answer very short. -3.84e+08. In the year 2000, what is the difference between the Grants(current US$) of St. Vincent and the Grenadines and Grants(current US$) of West Bank and Gaza?
Offer a very short reply. -5.35e+08. What is the ratio of the Grants(current US$) in Eritrea in 1993 to that in 1994?
Keep it short and to the point. 0.53. What is the ratio of the Grants(current US$) in Philippines in 1993 to that in 1994?
Keep it short and to the point. 0.95. What is the ratio of the Grants(current US$) in St. Vincent and the Grenadines in 1993 to that in 1994?
Provide a succinct answer. 1.02. What is the ratio of the Grants(current US$) in West Bank and Gaza in 1993 to that in 1994?
Offer a terse response. 0.39. What is the ratio of the Grants(current US$) of Eritrea in 1993 to that in 1995?
Provide a succinct answer. 0.59. What is the ratio of the Grants(current US$) in Philippines in 1993 to that in 1995?
Offer a very short reply. 0.97. What is the ratio of the Grants(current US$) of St. Vincent and the Grenadines in 1993 to that in 1995?
Provide a short and direct response. 0.08. What is the ratio of the Grants(current US$) of West Bank and Gaza in 1993 to that in 1995?
Keep it short and to the point. 0.31. What is the ratio of the Grants(current US$) in Eritrea in 1993 to that in 1996?
Your answer should be compact. 0.65. What is the ratio of the Grants(current US$) in Philippines in 1993 to that in 1996?
Your answer should be very brief. 1.09. What is the ratio of the Grants(current US$) in St. Vincent and the Grenadines in 1993 to that in 1996?
Offer a terse response. 0.17. What is the ratio of the Grants(current US$) in West Bank and Gaza in 1993 to that in 1996?
Give a very brief answer. 0.24. What is the ratio of the Grants(current US$) in Eritrea in 1993 to that in 1997?
Your answer should be very brief. 1.01. What is the ratio of the Grants(current US$) of Philippines in 1993 to that in 1997?
Your response must be concise. 1.39. What is the ratio of the Grants(current US$) in St. Vincent and the Grenadines in 1993 to that in 1997?
Provide a succinct answer. 0.81. What is the ratio of the Grants(current US$) in West Bank and Gaza in 1993 to that in 1997?
Ensure brevity in your answer.  0.17. What is the ratio of the Grants(current US$) of Eritrea in 1993 to that in 1998?
Make the answer very short. 0.82. What is the ratio of the Grants(current US$) in Philippines in 1993 to that in 1998?
Ensure brevity in your answer.  1.3. What is the ratio of the Grants(current US$) in St. Vincent and the Grenadines in 1993 to that in 1998?
Offer a very short reply. 0.3. What is the ratio of the Grants(current US$) of West Bank and Gaza in 1993 to that in 1998?
Give a very brief answer. 0.16. What is the ratio of the Grants(current US$) in Eritrea in 1993 to that in 1999?
Your response must be concise. 0.94. What is the ratio of the Grants(current US$) of Philippines in 1993 to that in 1999?
Keep it short and to the point. 1.56. What is the ratio of the Grants(current US$) in St. Vincent and the Grenadines in 1993 to that in 1999?
Offer a terse response. 0.26. What is the ratio of the Grants(current US$) of West Bank and Gaza in 1993 to that in 1999?
Your answer should be compact. 0.19. What is the ratio of the Grants(current US$) in Eritrea in 1993 to that in 2000?
Your answer should be compact. 0.57. What is the ratio of the Grants(current US$) in Philippines in 1993 to that in 2000?
Offer a very short reply. 1.75. What is the ratio of the Grants(current US$) of St. Vincent and the Grenadines in 1993 to that in 2000?
Offer a very short reply. 0.98. What is the ratio of the Grants(current US$) of West Bank and Gaza in 1993 to that in 2000?
Give a very brief answer. 0.14. What is the ratio of the Grants(current US$) in Eritrea in 1994 to that in 1995?
Ensure brevity in your answer.  1.1. What is the ratio of the Grants(current US$) in Philippines in 1994 to that in 1995?
Make the answer very short. 1.03. What is the ratio of the Grants(current US$) of St. Vincent and the Grenadines in 1994 to that in 1995?
Your answer should be very brief. 0.08. What is the ratio of the Grants(current US$) in West Bank and Gaza in 1994 to that in 1995?
Offer a very short reply. 0.79. What is the ratio of the Grants(current US$) in Eritrea in 1994 to that in 1996?
Your response must be concise. 1.24. What is the ratio of the Grants(current US$) of Philippines in 1994 to that in 1996?
Make the answer very short. 1.16. What is the ratio of the Grants(current US$) in St. Vincent and the Grenadines in 1994 to that in 1996?
Provide a succinct answer. 0.17. What is the ratio of the Grants(current US$) in West Bank and Gaza in 1994 to that in 1996?
Your response must be concise. 0.61. What is the ratio of the Grants(current US$) of Eritrea in 1994 to that in 1997?
Provide a succinct answer. 1.9. What is the ratio of the Grants(current US$) in Philippines in 1994 to that in 1997?
Offer a terse response. 1.47. What is the ratio of the Grants(current US$) in St. Vincent and the Grenadines in 1994 to that in 1997?
Offer a terse response. 0.8. What is the ratio of the Grants(current US$) in West Bank and Gaza in 1994 to that in 1997?
Offer a very short reply. 0.43. What is the ratio of the Grants(current US$) in Eritrea in 1994 to that in 1998?
Provide a succinct answer. 1.54. What is the ratio of the Grants(current US$) of Philippines in 1994 to that in 1998?
Keep it short and to the point. 1.38. What is the ratio of the Grants(current US$) of St. Vincent and the Grenadines in 1994 to that in 1998?
Your response must be concise. 0.3. What is the ratio of the Grants(current US$) in West Bank and Gaza in 1994 to that in 1998?
Your response must be concise. 0.41. What is the ratio of the Grants(current US$) in Eritrea in 1994 to that in 1999?
Offer a very short reply. 1.78. What is the ratio of the Grants(current US$) of Philippines in 1994 to that in 1999?
Keep it short and to the point. 1.65. What is the ratio of the Grants(current US$) of St. Vincent and the Grenadines in 1994 to that in 1999?
Your answer should be compact. 0.26. What is the ratio of the Grants(current US$) of West Bank and Gaza in 1994 to that in 1999?
Ensure brevity in your answer.  0.49. What is the ratio of the Grants(current US$) in Eritrea in 1994 to that in 2000?
Keep it short and to the point. 1.08. What is the ratio of the Grants(current US$) of Philippines in 1994 to that in 2000?
Ensure brevity in your answer.  1.85. What is the ratio of the Grants(current US$) of St. Vincent and the Grenadines in 1994 to that in 2000?
Offer a terse response. 0.97. What is the ratio of the Grants(current US$) in West Bank and Gaza in 1994 to that in 2000?
Your response must be concise. 0.37. What is the ratio of the Grants(current US$) in Eritrea in 1995 to that in 1996?
Provide a succinct answer. 1.12. What is the ratio of the Grants(current US$) of Philippines in 1995 to that in 1996?
Make the answer very short. 1.12. What is the ratio of the Grants(current US$) in St. Vincent and the Grenadines in 1995 to that in 1996?
Keep it short and to the point. 2.24. What is the ratio of the Grants(current US$) of West Bank and Gaza in 1995 to that in 1996?
Your response must be concise. 0.78. What is the ratio of the Grants(current US$) in Eritrea in 1995 to that in 1997?
Offer a terse response. 1.72. What is the ratio of the Grants(current US$) of Philippines in 1995 to that in 1997?
Offer a terse response. 1.43. What is the ratio of the Grants(current US$) in St. Vincent and the Grenadines in 1995 to that in 1997?
Offer a terse response. 10.57. What is the ratio of the Grants(current US$) of West Bank and Gaza in 1995 to that in 1997?
Your answer should be very brief. 0.54. What is the ratio of the Grants(current US$) of Eritrea in 1995 to that in 1998?
Ensure brevity in your answer.  1.4. What is the ratio of the Grants(current US$) in Philippines in 1995 to that in 1998?
Your response must be concise. 1.34. What is the ratio of the Grants(current US$) in St. Vincent and the Grenadines in 1995 to that in 1998?
Make the answer very short. 3.97. What is the ratio of the Grants(current US$) of West Bank and Gaza in 1995 to that in 1998?
Keep it short and to the point. 0.52. What is the ratio of the Grants(current US$) of Eritrea in 1995 to that in 1999?
Provide a succinct answer. 1.61. What is the ratio of the Grants(current US$) in Philippines in 1995 to that in 1999?
Keep it short and to the point. 1.6. What is the ratio of the Grants(current US$) of St. Vincent and the Grenadines in 1995 to that in 1999?
Your answer should be compact. 3.44. What is the ratio of the Grants(current US$) of West Bank and Gaza in 1995 to that in 1999?
Keep it short and to the point. 0.62. What is the ratio of the Grants(current US$) in Eritrea in 1995 to that in 2000?
Your response must be concise. 0.98. What is the ratio of the Grants(current US$) in Philippines in 1995 to that in 2000?
Ensure brevity in your answer.  1.79. What is the ratio of the Grants(current US$) in St. Vincent and the Grenadines in 1995 to that in 2000?
Ensure brevity in your answer.  12.81. What is the ratio of the Grants(current US$) in West Bank and Gaza in 1995 to that in 2000?
Your response must be concise. 0.46. What is the ratio of the Grants(current US$) of Eritrea in 1996 to that in 1997?
Your response must be concise. 1.54. What is the ratio of the Grants(current US$) in Philippines in 1996 to that in 1997?
Make the answer very short. 1.27. What is the ratio of the Grants(current US$) of St. Vincent and the Grenadines in 1996 to that in 1997?
Your answer should be compact. 4.72. What is the ratio of the Grants(current US$) of West Bank and Gaza in 1996 to that in 1997?
Your answer should be compact. 0.69. What is the ratio of the Grants(current US$) of Eritrea in 1996 to that in 1998?
Your answer should be very brief. 1.25. What is the ratio of the Grants(current US$) in Philippines in 1996 to that in 1998?
Keep it short and to the point. 1.19. What is the ratio of the Grants(current US$) in St. Vincent and the Grenadines in 1996 to that in 1998?
Offer a very short reply. 1.77. What is the ratio of the Grants(current US$) of West Bank and Gaza in 1996 to that in 1998?
Your answer should be very brief. 0.67. What is the ratio of the Grants(current US$) of Eritrea in 1996 to that in 1999?
Your response must be concise. 1.44. What is the ratio of the Grants(current US$) in Philippines in 1996 to that in 1999?
Your answer should be compact. 1.43. What is the ratio of the Grants(current US$) in St. Vincent and the Grenadines in 1996 to that in 1999?
Give a very brief answer. 1.54. What is the ratio of the Grants(current US$) in West Bank and Gaza in 1996 to that in 1999?
Offer a very short reply. 0.8. What is the ratio of the Grants(current US$) in Eritrea in 1996 to that in 2000?
Offer a very short reply. 0.87. What is the ratio of the Grants(current US$) of Philippines in 1996 to that in 2000?
Keep it short and to the point. 1.6. What is the ratio of the Grants(current US$) in St. Vincent and the Grenadines in 1996 to that in 2000?
Offer a terse response. 5.72. What is the ratio of the Grants(current US$) of West Bank and Gaza in 1996 to that in 2000?
Keep it short and to the point. 0.6. What is the ratio of the Grants(current US$) of Eritrea in 1997 to that in 1998?
Your answer should be compact. 0.81. What is the ratio of the Grants(current US$) in Philippines in 1997 to that in 1998?
Give a very brief answer. 0.94. What is the ratio of the Grants(current US$) of St. Vincent and the Grenadines in 1997 to that in 1998?
Ensure brevity in your answer.  0.38. What is the ratio of the Grants(current US$) of West Bank and Gaza in 1997 to that in 1998?
Offer a very short reply. 0.97. What is the ratio of the Grants(current US$) of Eritrea in 1997 to that in 1999?
Give a very brief answer. 0.94. What is the ratio of the Grants(current US$) in Philippines in 1997 to that in 1999?
Provide a succinct answer. 1.12. What is the ratio of the Grants(current US$) in St. Vincent and the Grenadines in 1997 to that in 1999?
Your answer should be very brief. 0.33. What is the ratio of the Grants(current US$) of West Bank and Gaza in 1997 to that in 1999?
Provide a succinct answer. 1.16. What is the ratio of the Grants(current US$) in Eritrea in 1997 to that in 2000?
Your response must be concise. 0.57. What is the ratio of the Grants(current US$) in Philippines in 1997 to that in 2000?
Offer a very short reply. 1.25. What is the ratio of the Grants(current US$) in St. Vincent and the Grenadines in 1997 to that in 2000?
Ensure brevity in your answer.  1.21. What is the ratio of the Grants(current US$) in West Bank and Gaza in 1997 to that in 2000?
Ensure brevity in your answer.  0.86. What is the ratio of the Grants(current US$) in Eritrea in 1998 to that in 1999?
Provide a short and direct response. 1.15. What is the ratio of the Grants(current US$) in Philippines in 1998 to that in 1999?
Your answer should be very brief. 1.2. What is the ratio of the Grants(current US$) of St. Vincent and the Grenadines in 1998 to that in 1999?
Keep it short and to the point. 0.87. What is the ratio of the Grants(current US$) of West Bank and Gaza in 1998 to that in 1999?
Your response must be concise. 1.2. What is the ratio of the Grants(current US$) of Eritrea in 1998 to that in 2000?
Make the answer very short. 0.7. What is the ratio of the Grants(current US$) in Philippines in 1998 to that in 2000?
Your response must be concise. 1.34. What is the ratio of the Grants(current US$) in St. Vincent and the Grenadines in 1998 to that in 2000?
Make the answer very short. 3.23. What is the ratio of the Grants(current US$) in West Bank and Gaza in 1998 to that in 2000?
Ensure brevity in your answer.  0.89. What is the ratio of the Grants(current US$) in Eritrea in 1999 to that in 2000?
Your response must be concise. 0.61. What is the ratio of the Grants(current US$) in Philippines in 1999 to that in 2000?
Your response must be concise. 1.12. What is the ratio of the Grants(current US$) of St. Vincent and the Grenadines in 1999 to that in 2000?
Offer a very short reply. 3.72. What is the ratio of the Grants(current US$) in West Bank and Gaza in 1999 to that in 2000?
Your answer should be compact. 0.74. What is the difference between the highest and the second highest Grants(current US$) of Eritrea?
Provide a short and direct response. 8.42e+06. What is the difference between the highest and the second highest Grants(current US$) in Philippines?
Give a very brief answer. 8.22e+06. What is the difference between the highest and the second highest Grants(current US$) of St. Vincent and the Grenadines?
Give a very brief answer. 2.54e+07. What is the difference between the highest and the second highest Grants(current US$) of West Bank and Gaza?
Your answer should be compact. 5.79e+07. What is the difference between the highest and the lowest Grants(current US$) of Eritrea?
Provide a succinct answer. 5.39e+07. What is the difference between the highest and the lowest Grants(current US$) in Philippines?
Your answer should be very brief. 1.31e+08. What is the difference between the highest and the lowest Grants(current US$) in St. Vincent and the Grenadines?
Your response must be concise. 4.25e+07. What is the difference between the highest and the lowest Grants(current US$) of West Bank and Gaza?
Keep it short and to the point. 4.61e+08. 